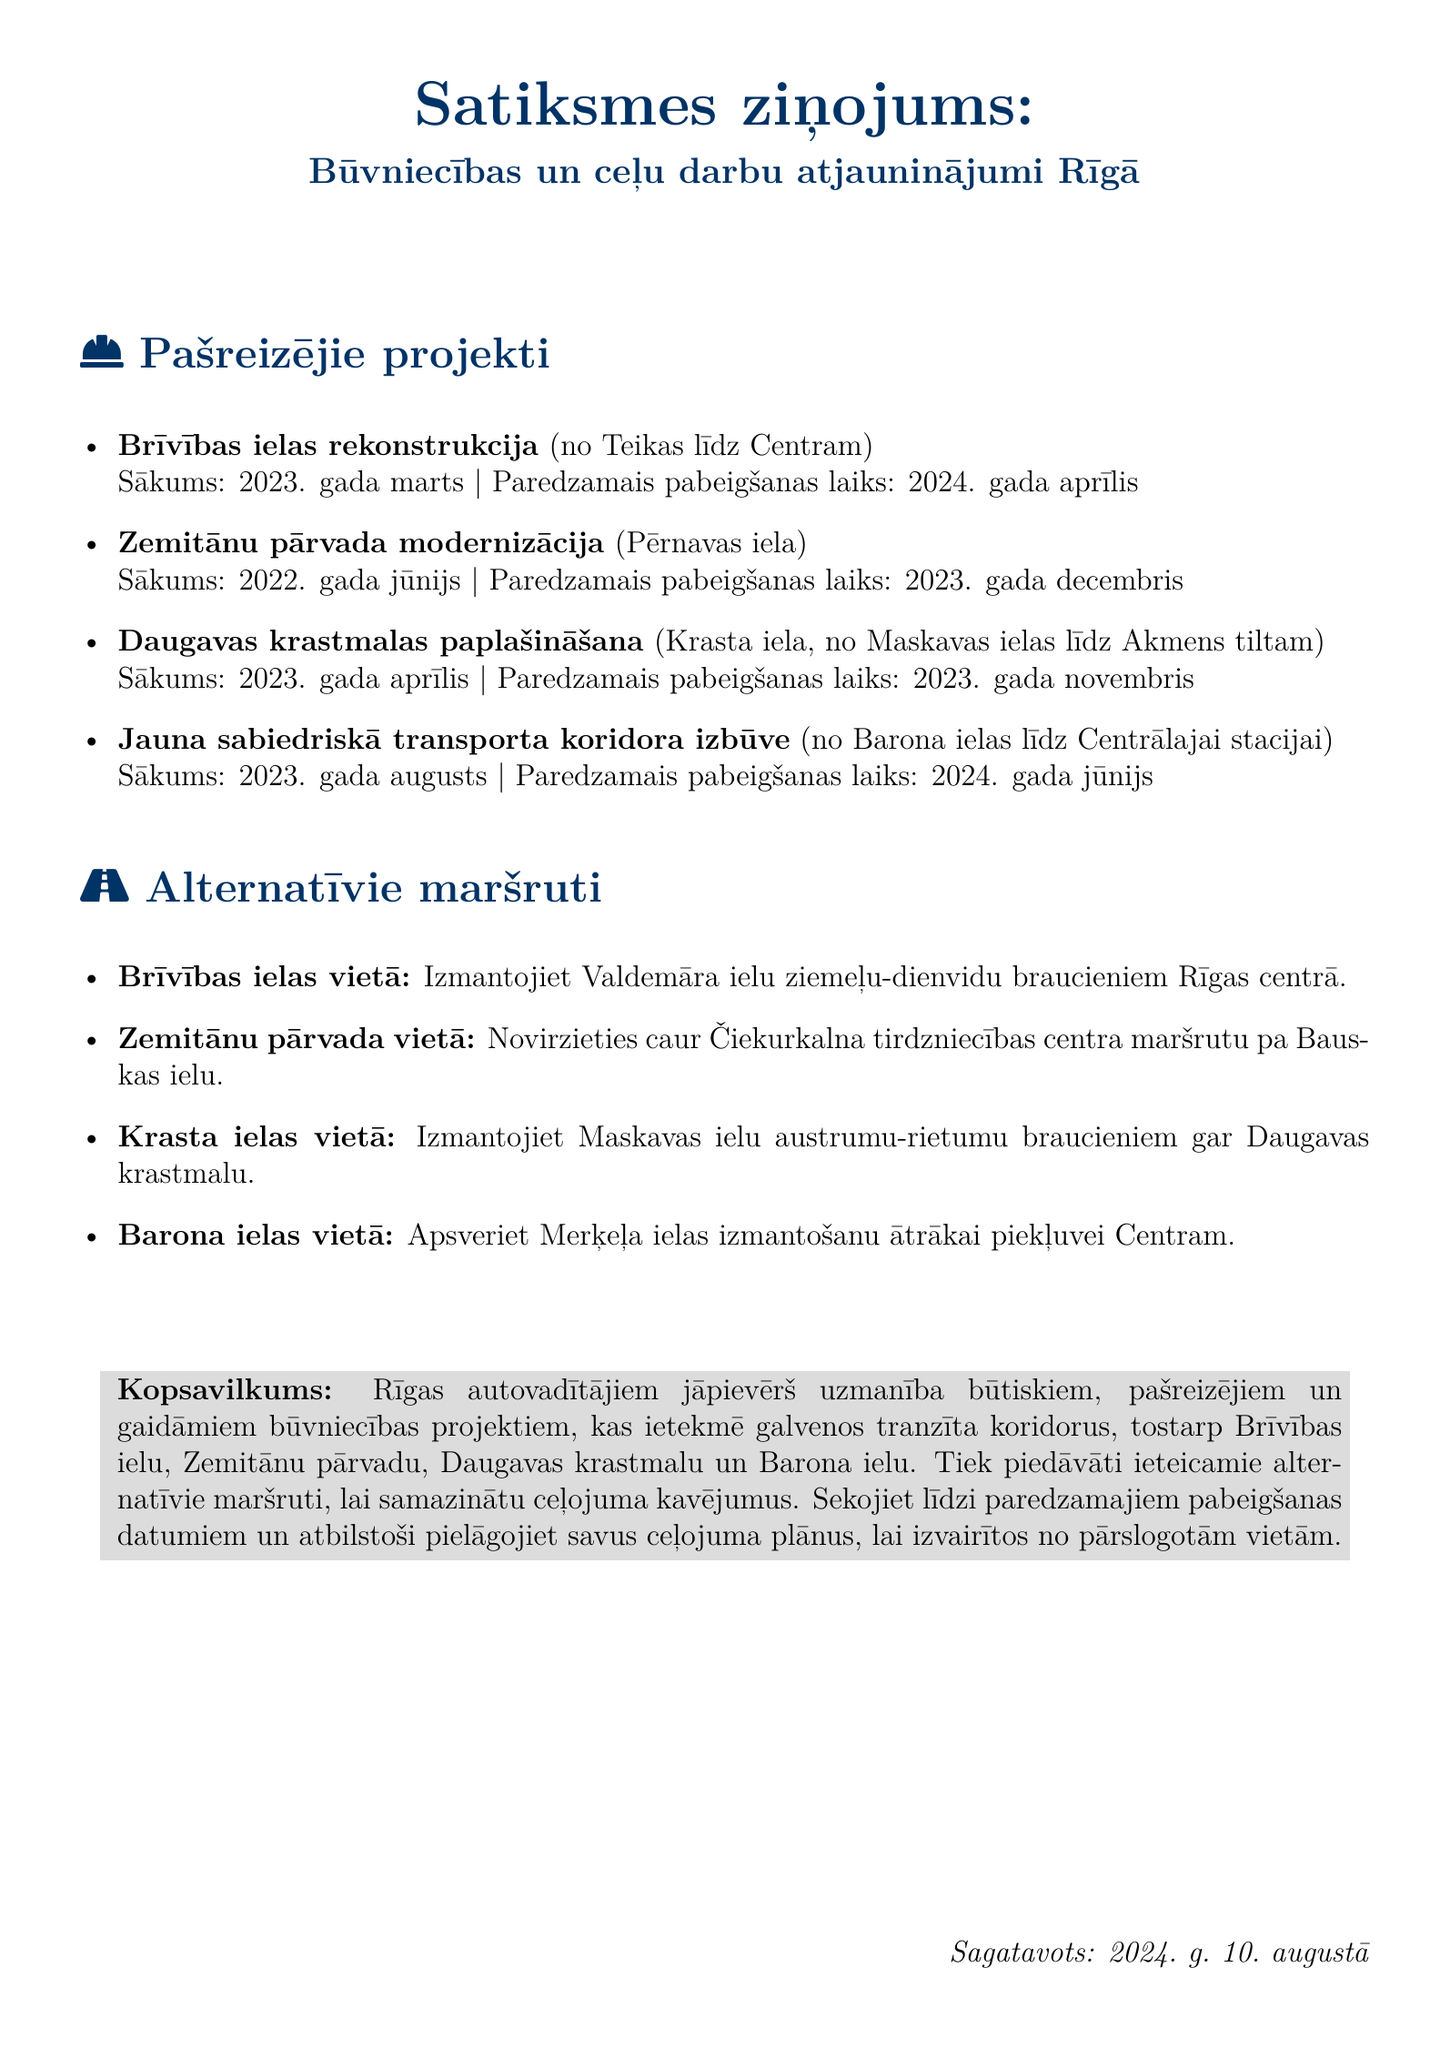what is the title of the report? The title is the header of the document, which states the overall subject being discussed.
Answer: Satiksmes ziņojums: Būvniecības un ceļu darbu atjauninājumi Rīgā when did the Brīvības ielas rekonstrukcija project start? The start date for this project is explicitly mentioned in the document.
Answer: 2023. gada marts what is the expected completion date for the Daugavas krastmalas paplašināšana project? The document provides a specific expected completion date for this project.
Answer: 2023. gada novembris which road is suggested as an alternative to Brīvības iela? The alternative route is clearly stated in the document under the corresponding section.
Answer: Valdemāra iela how long is the Zemitānu pārvada modernizācija project expected to last? The expected duration can be deduced from the start and completion dates provided in the document.
Answer: 1.5 years which project is scheduled to complete in June 2024? This question requires identifying the project mentioned in the document with the given completion date.
Answer: Jauna sabiedriskā transporta koridora izbūve what is the main purpose of the document? The purpose can be inferred from the introduction and the content laid out in the document.
Answer: Provide construction and roadwork updates how many ongoing construction projects are listed in the document? The total number of projects can be counted from the list provided.
Answer: 4 